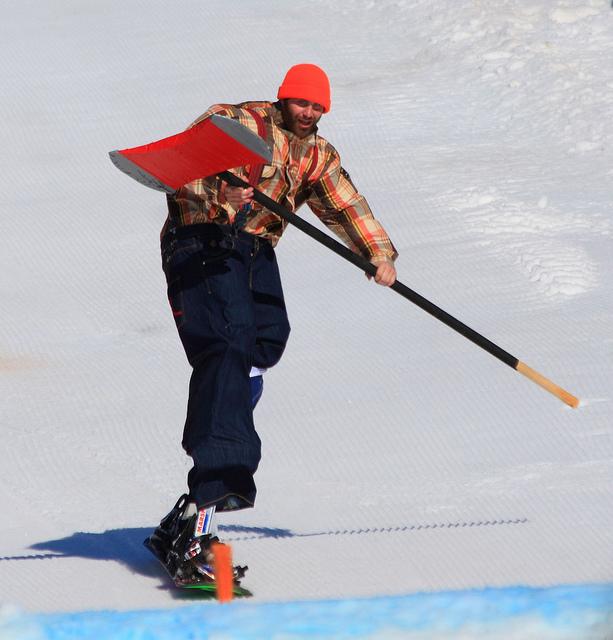What is the man doing?
Answer briefly. Snowboarding. What is the man carrying?
Concise answer only. Ax. What is this man pretending to be?
Short answer required. Lumberjack. What color is his jacket?
Concise answer only. Plaid. What color is the man's hat?
Be succinct. Orange. 